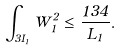<formula> <loc_0><loc_0><loc_500><loc_500>\int _ { 3 I _ { 1 } } W _ { 1 } ^ { 2 } \leq \frac { 1 3 4 } { L _ { 1 } } .</formula> 